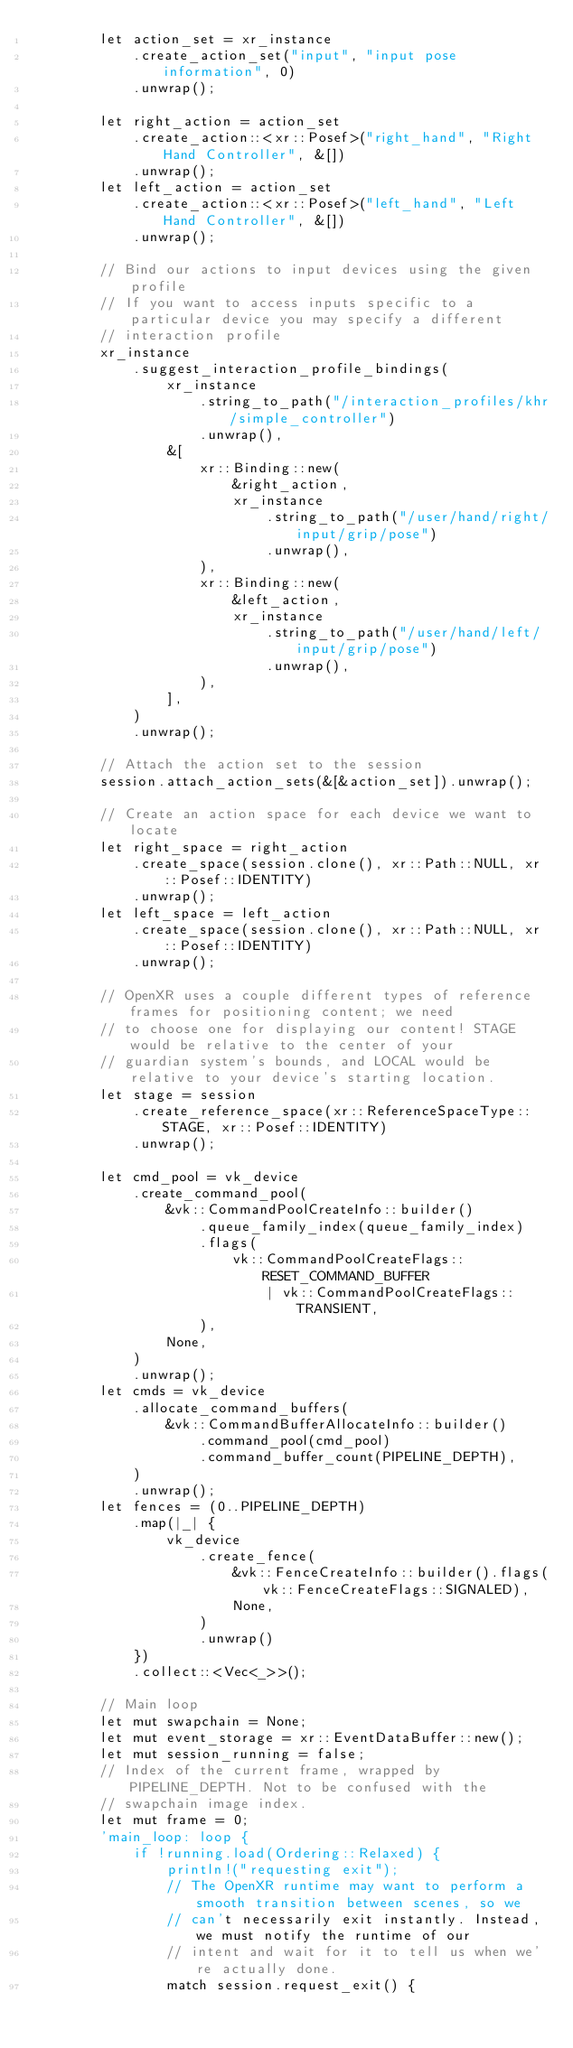Convert code to text. <code><loc_0><loc_0><loc_500><loc_500><_Rust_>        let action_set = xr_instance
            .create_action_set("input", "input pose information", 0)
            .unwrap();

        let right_action = action_set
            .create_action::<xr::Posef>("right_hand", "Right Hand Controller", &[])
            .unwrap();
        let left_action = action_set
            .create_action::<xr::Posef>("left_hand", "Left Hand Controller", &[])
            .unwrap();

        // Bind our actions to input devices using the given profile
        // If you want to access inputs specific to a particular device you may specify a different
        // interaction profile
        xr_instance
            .suggest_interaction_profile_bindings(
                xr_instance
                    .string_to_path("/interaction_profiles/khr/simple_controller")
                    .unwrap(),
                &[
                    xr::Binding::new(
                        &right_action,
                        xr_instance
                            .string_to_path("/user/hand/right/input/grip/pose")
                            .unwrap(),
                    ),
                    xr::Binding::new(
                        &left_action,
                        xr_instance
                            .string_to_path("/user/hand/left/input/grip/pose")
                            .unwrap(),
                    ),
                ],
            )
            .unwrap();

        // Attach the action set to the session
        session.attach_action_sets(&[&action_set]).unwrap();

        // Create an action space for each device we want to locate
        let right_space = right_action
            .create_space(session.clone(), xr::Path::NULL, xr::Posef::IDENTITY)
            .unwrap();
        let left_space = left_action
            .create_space(session.clone(), xr::Path::NULL, xr::Posef::IDENTITY)
            .unwrap();

        // OpenXR uses a couple different types of reference frames for positioning content; we need
        // to choose one for displaying our content! STAGE would be relative to the center of your
        // guardian system's bounds, and LOCAL would be relative to your device's starting location.
        let stage = session
            .create_reference_space(xr::ReferenceSpaceType::STAGE, xr::Posef::IDENTITY)
            .unwrap();

        let cmd_pool = vk_device
            .create_command_pool(
                &vk::CommandPoolCreateInfo::builder()
                    .queue_family_index(queue_family_index)
                    .flags(
                        vk::CommandPoolCreateFlags::RESET_COMMAND_BUFFER
                            | vk::CommandPoolCreateFlags::TRANSIENT,
                    ),
                None,
            )
            .unwrap();
        let cmds = vk_device
            .allocate_command_buffers(
                &vk::CommandBufferAllocateInfo::builder()
                    .command_pool(cmd_pool)
                    .command_buffer_count(PIPELINE_DEPTH),
            )
            .unwrap();
        let fences = (0..PIPELINE_DEPTH)
            .map(|_| {
                vk_device
                    .create_fence(
                        &vk::FenceCreateInfo::builder().flags(vk::FenceCreateFlags::SIGNALED),
                        None,
                    )
                    .unwrap()
            })
            .collect::<Vec<_>>();

        // Main loop
        let mut swapchain = None;
        let mut event_storage = xr::EventDataBuffer::new();
        let mut session_running = false;
        // Index of the current frame, wrapped by PIPELINE_DEPTH. Not to be confused with the
        // swapchain image index.
        let mut frame = 0;
        'main_loop: loop {
            if !running.load(Ordering::Relaxed) {
                println!("requesting exit");
                // The OpenXR runtime may want to perform a smooth transition between scenes, so we
                // can't necessarily exit instantly. Instead, we must notify the runtime of our
                // intent and wait for it to tell us when we're actually done.
                match session.request_exit() {</code> 